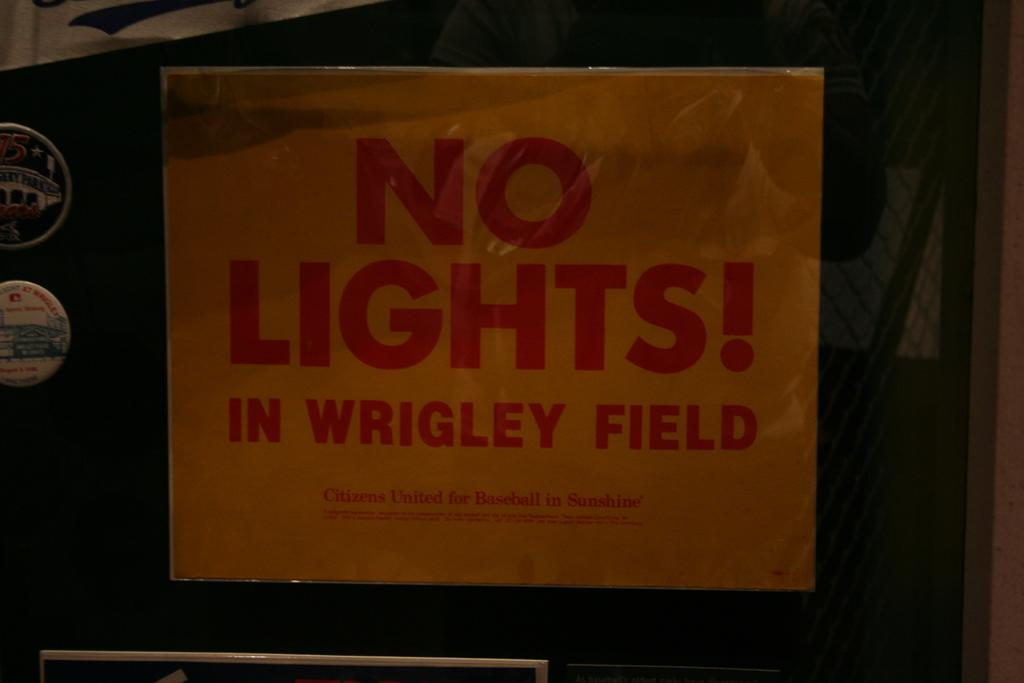<image>
Present a compact description of the photo's key features. An old looking piece of paper that read No Light! In wrigley field. 